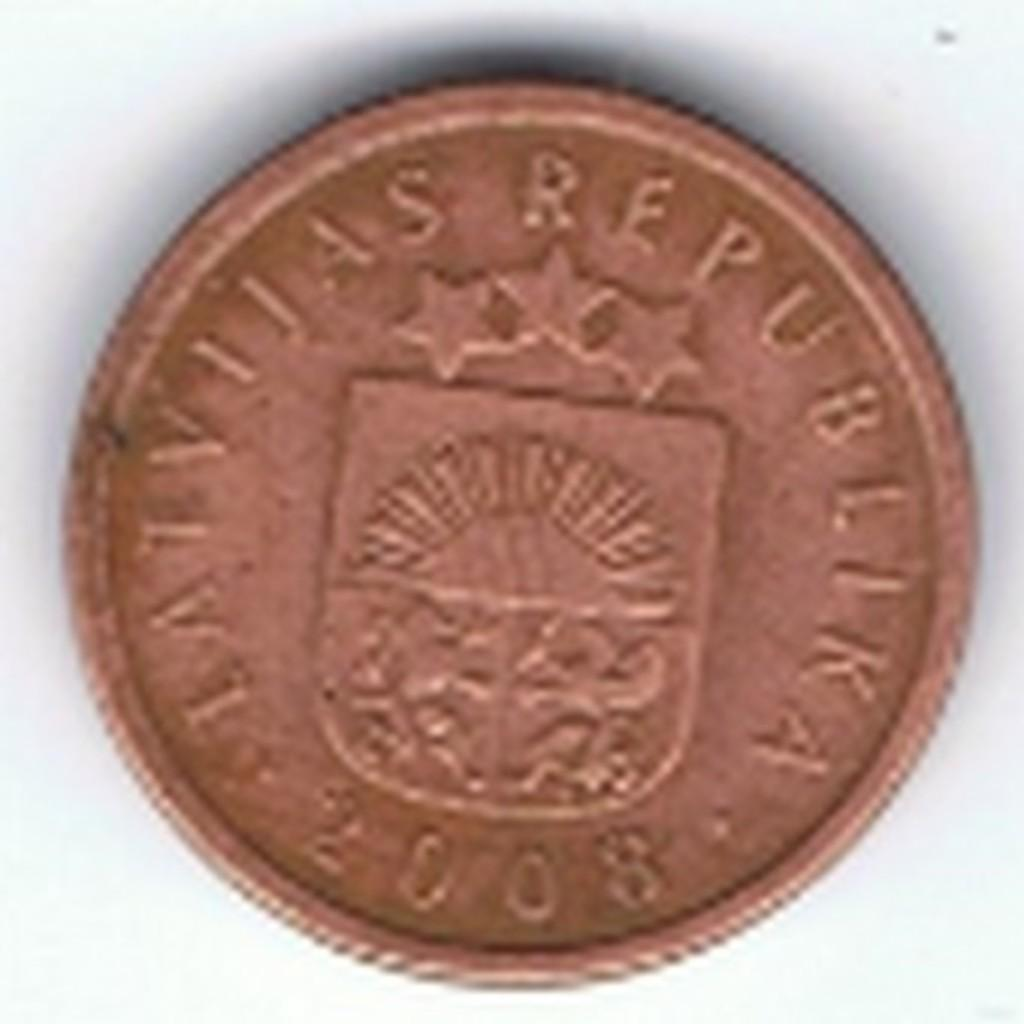Provide a one-sentence caption for the provided image. A very blurry picture of an latvijas republika 2008 coin. 